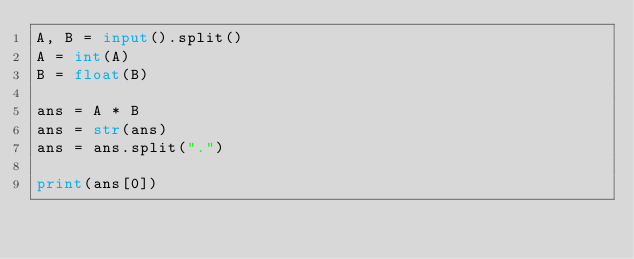Convert code to text. <code><loc_0><loc_0><loc_500><loc_500><_Python_>A, B = input().split()
A = int(A)
B = float(B)

ans = A * B
ans = str(ans)
ans = ans.split(".")

print(ans[0])
</code> 